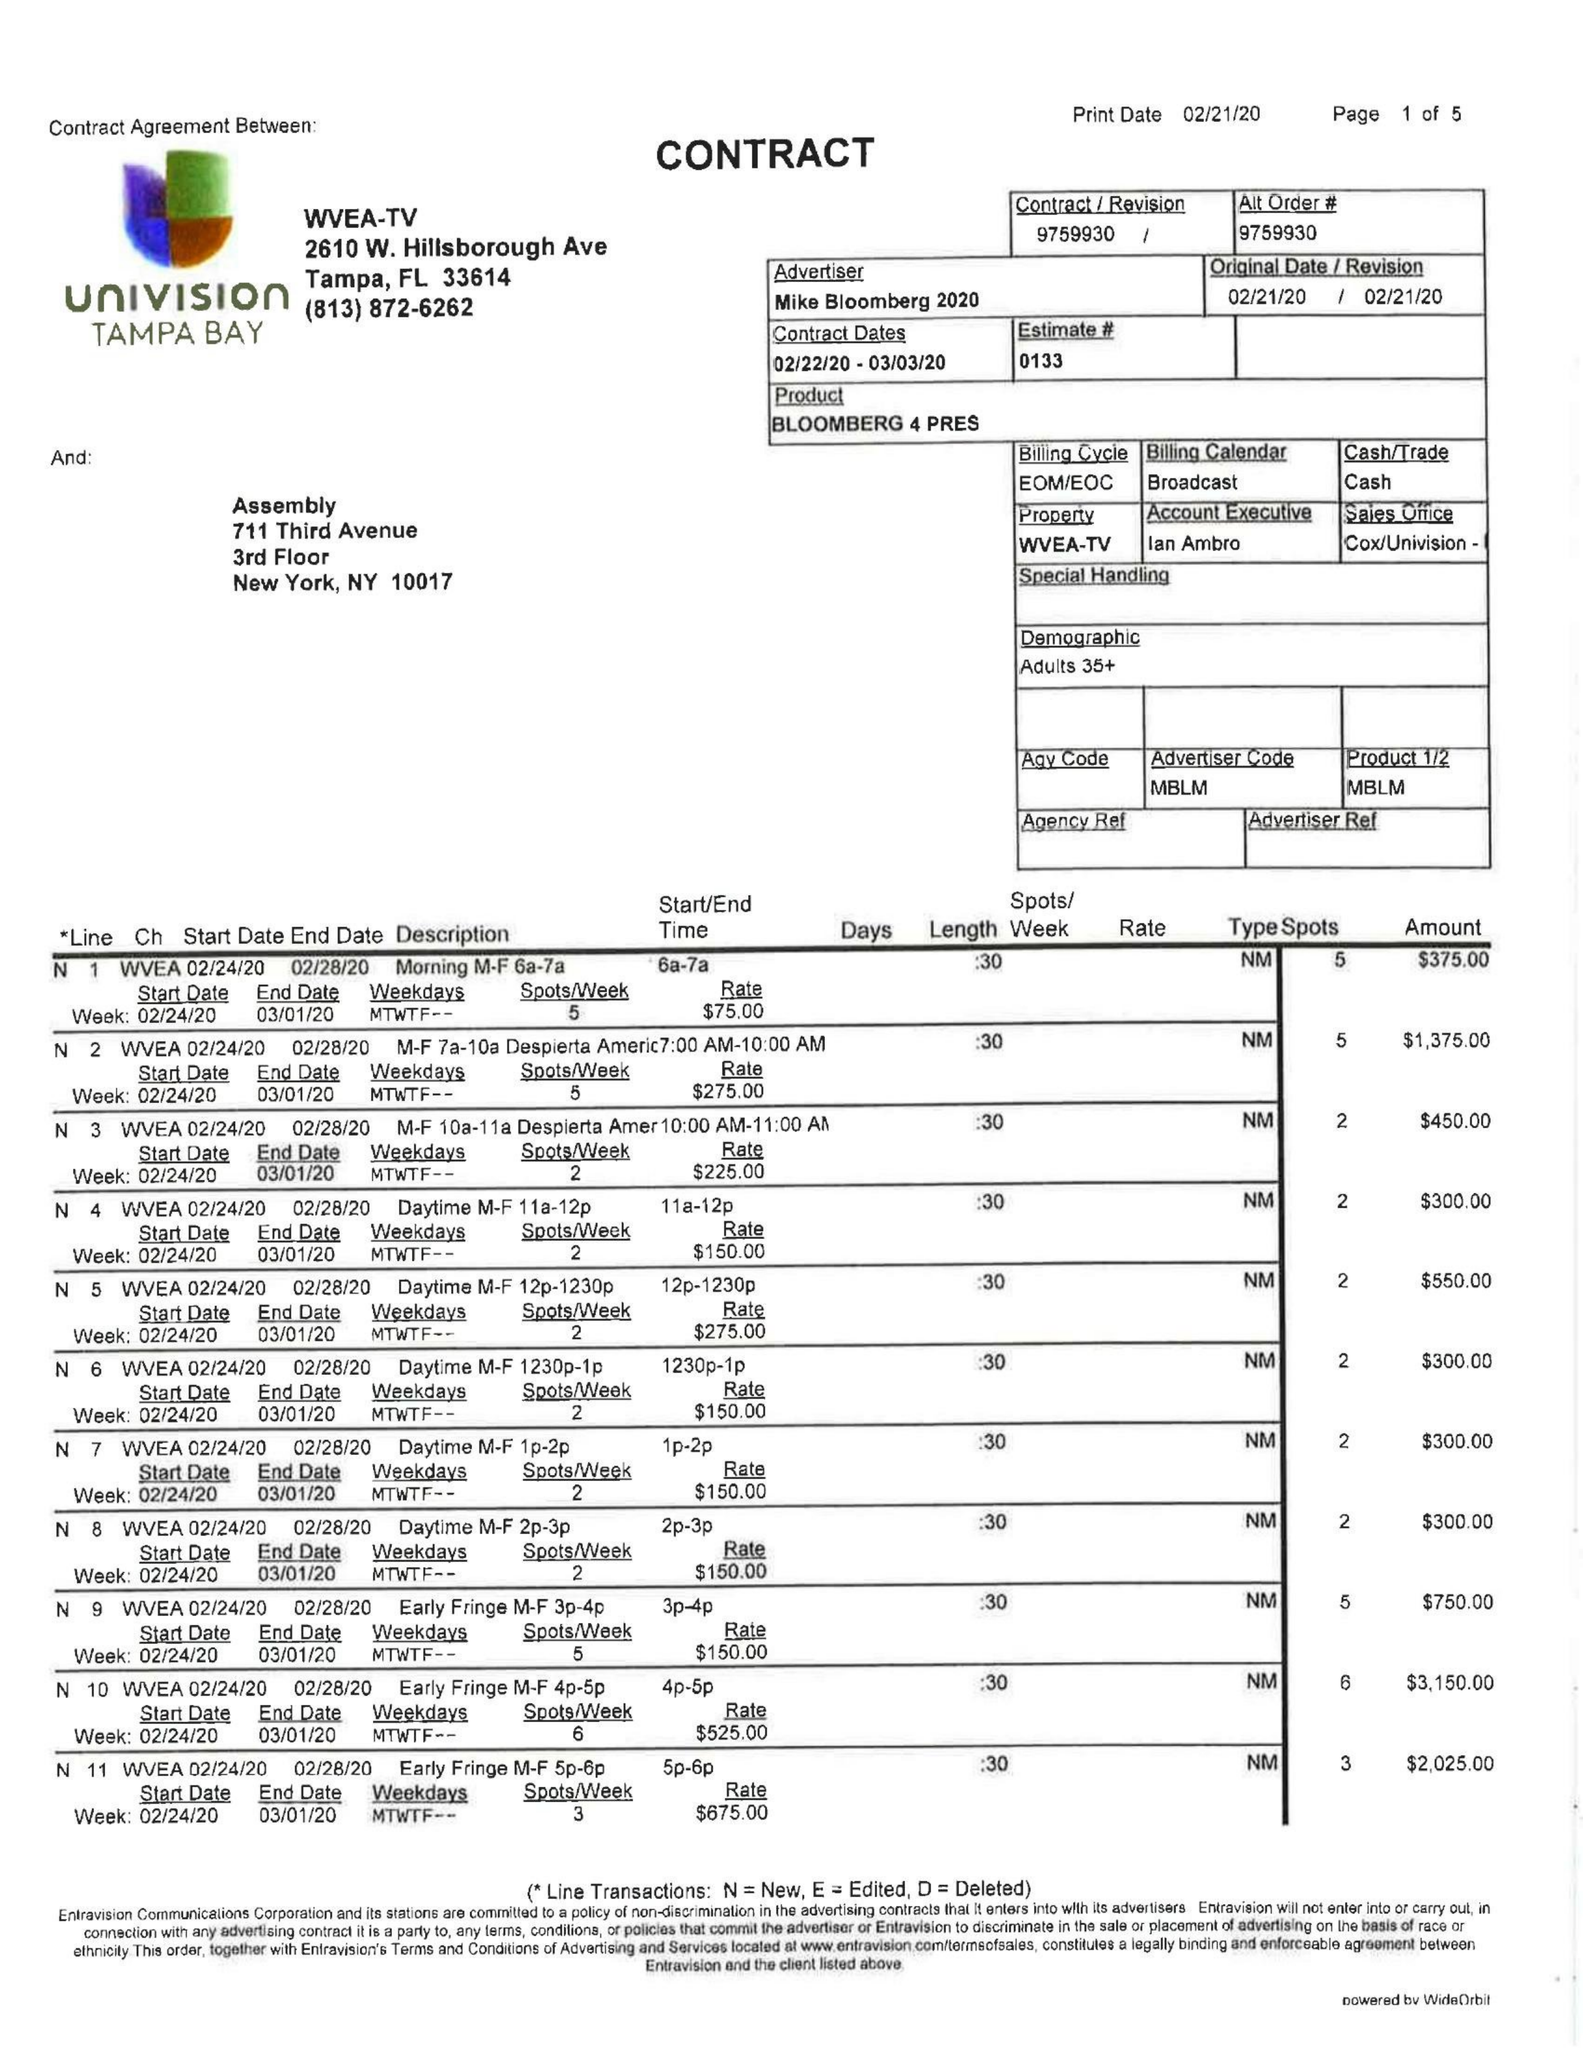What is the value for the gross_amount?
Answer the question using a single word or phrase. 42700.00 